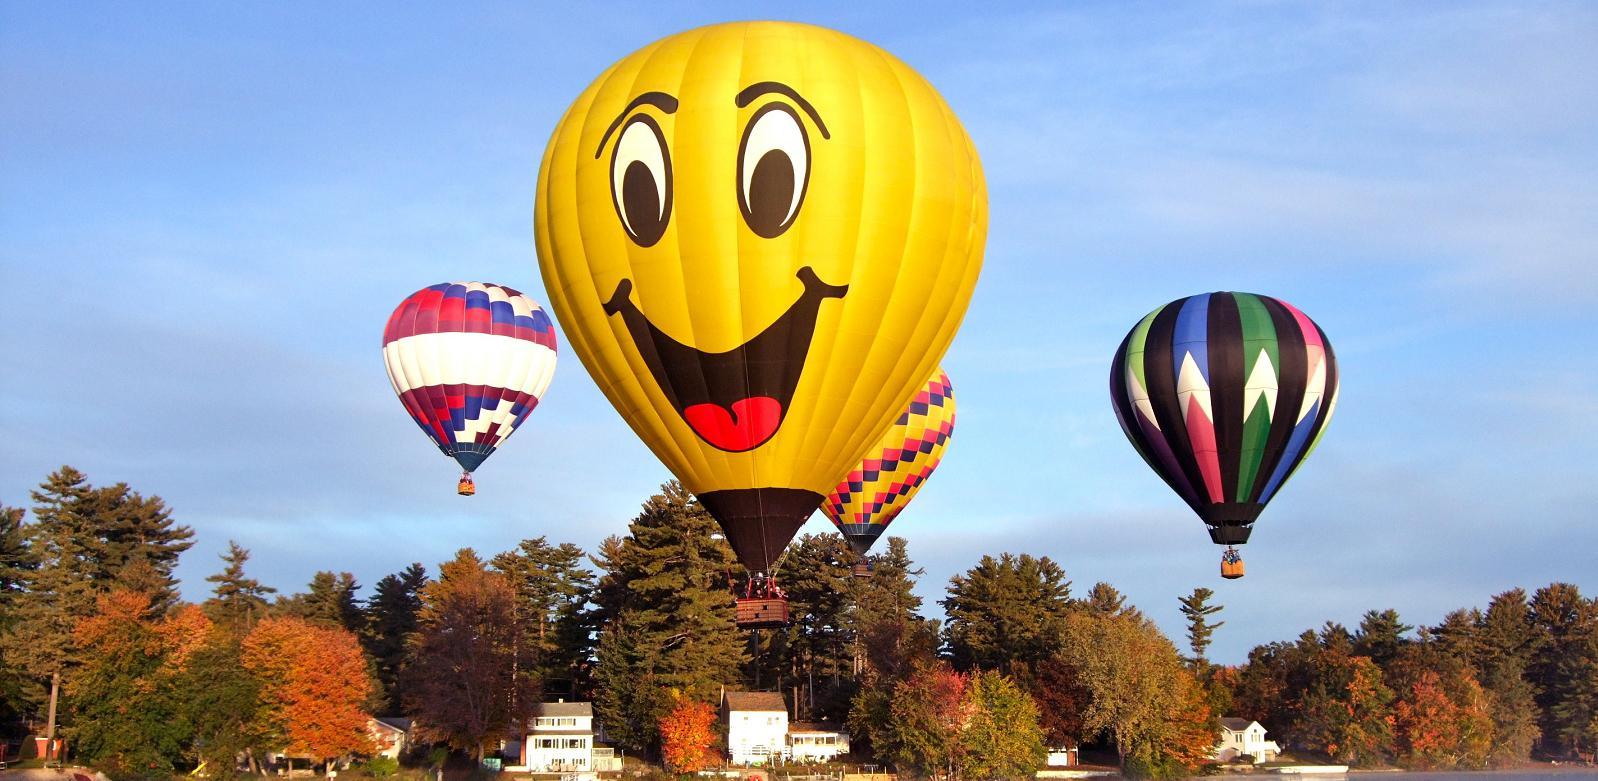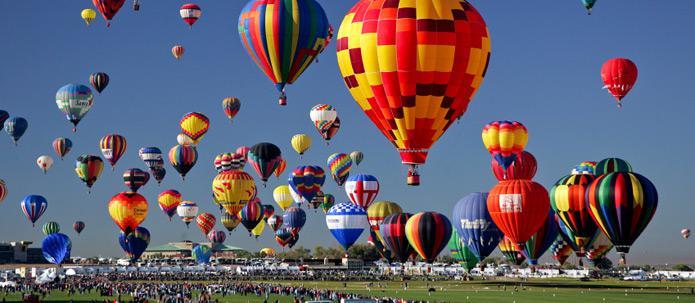The first image is the image on the left, the second image is the image on the right. For the images shown, is this caption "In one image, the balloon in the foreground has a face." true? Answer yes or no. Yes. The first image is the image on the left, the second image is the image on the right. Assess this claim about the two images: "In one image, a face is designed on the side of a large yellow hot-air balloon.". Correct or not? Answer yes or no. Yes. 